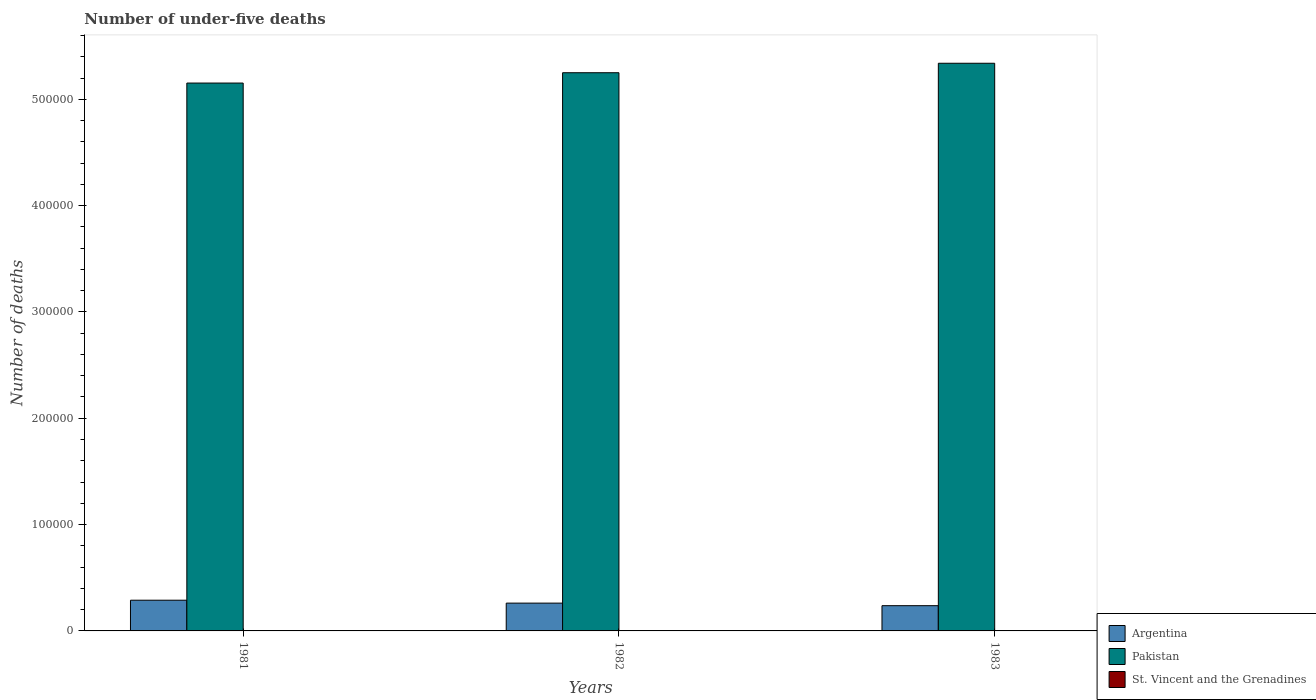Are the number of bars per tick equal to the number of legend labels?
Provide a succinct answer. Yes. Are the number of bars on each tick of the X-axis equal?
Your response must be concise. Yes. How many bars are there on the 2nd tick from the left?
Ensure brevity in your answer.  3. What is the label of the 2nd group of bars from the left?
Keep it short and to the point. 1982. What is the number of under-five deaths in St. Vincent and the Grenadines in 1982?
Make the answer very short. 140. Across all years, what is the maximum number of under-five deaths in Pakistan?
Give a very brief answer. 5.34e+05. Across all years, what is the minimum number of under-five deaths in Pakistan?
Keep it short and to the point. 5.15e+05. In which year was the number of under-five deaths in Pakistan maximum?
Make the answer very short. 1983. In which year was the number of under-five deaths in Argentina minimum?
Your response must be concise. 1983. What is the total number of under-five deaths in Argentina in the graph?
Provide a succinct answer. 7.88e+04. What is the difference between the number of under-five deaths in Pakistan in 1981 and that in 1982?
Make the answer very short. -9711. What is the difference between the number of under-five deaths in Argentina in 1982 and the number of under-five deaths in Pakistan in 1983?
Make the answer very short. -5.08e+05. What is the average number of under-five deaths in Pakistan per year?
Your answer should be very brief. 5.25e+05. In the year 1981, what is the difference between the number of under-five deaths in St. Vincent and the Grenadines and number of under-five deaths in Pakistan?
Give a very brief answer. -5.15e+05. What is the ratio of the number of under-five deaths in St. Vincent and the Grenadines in 1982 to that in 1983?
Your answer should be very brief. 1.11. Is the difference between the number of under-five deaths in St. Vincent and the Grenadines in 1982 and 1983 greater than the difference between the number of under-five deaths in Pakistan in 1982 and 1983?
Offer a very short reply. Yes. What is the difference between the highest and the lowest number of under-five deaths in St. Vincent and the Grenadines?
Your response must be concise. 30. Is the sum of the number of under-five deaths in St. Vincent and the Grenadines in 1981 and 1982 greater than the maximum number of under-five deaths in Argentina across all years?
Provide a short and direct response. No. What does the 1st bar from the left in 1982 represents?
Your response must be concise. Argentina. What does the 2nd bar from the right in 1981 represents?
Make the answer very short. Pakistan. How many bars are there?
Keep it short and to the point. 9. What is the difference between two consecutive major ticks on the Y-axis?
Keep it short and to the point. 1.00e+05. How many legend labels are there?
Your response must be concise. 3. What is the title of the graph?
Keep it short and to the point. Number of under-five deaths. What is the label or title of the Y-axis?
Give a very brief answer. Number of deaths. What is the Number of deaths in Argentina in 1981?
Give a very brief answer. 2.89e+04. What is the Number of deaths of Pakistan in 1981?
Your response must be concise. 5.15e+05. What is the Number of deaths of St. Vincent and the Grenadines in 1981?
Make the answer very short. 156. What is the Number of deaths of Argentina in 1982?
Offer a terse response. 2.61e+04. What is the Number of deaths of Pakistan in 1982?
Your response must be concise. 5.25e+05. What is the Number of deaths of St. Vincent and the Grenadines in 1982?
Your answer should be compact. 140. What is the Number of deaths of Argentina in 1983?
Keep it short and to the point. 2.37e+04. What is the Number of deaths of Pakistan in 1983?
Your response must be concise. 5.34e+05. What is the Number of deaths in St. Vincent and the Grenadines in 1983?
Ensure brevity in your answer.  126. Across all years, what is the maximum Number of deaths in Argentina?
Provide a short and direct response. 2.89e+04. Across all years, what is the maximum Number of deaths of Pakistan?
Provide a succinct answer. 5.34e+05. Across all years, what is the maximum Number of deaths in St. Vincent and the Grenadines?
Offer a terse response. 156. Across all years, what is the minimum Number of deaths in Argentina?
Your response must be concise. 2.37e+04. Across all years, what is the minimum Number of deaths in Pakistan?
Provide a short and direct response. 5.15e+05. Across all years, what is the minimum Number of deaths in St. Vincent and the Grenadines?
Your response must be concise. 126. What is the total Number of deaths of Argentina in the graph?
Your answer should be very brief. 7.88e+04. What is the total Number of deaths in Pakistan in the graph?
Provide a succinct answer. 1.57e+06. What is the total Number of deaths of St. Vincent and the Grenadines in the graph?
Your response must be concise. 422. What is the difference between the Number of deaths in Argentina in 1981 and that in 1982?
Make the answer very short. 2733. What is the difference between the Number of deaths of Pakistan in 1981 and that in 1982?
Provide a short and direct response. -9711. What is the difference between the Number of deaths in Argentina in 1981 and that in 1983?
Your answer should be compact. 5147. What is the difference between the Number of deaths in Pakistan in 1981 and that in 1983?
Your answer should be very brief. -1.86e+04. What is the difference between the Number of deaths of St. Vincent and the Grenadines in 1981 and that in 1983?
Keep it short and to the point. 30. What is the difference between the Number of deaths of Argentina in 1982 and that in 1983?
Make the answer very short. 2414. What is the difference between the Number of deaths of Pakistan in 1982 and that in 1983?
Your response must be concise. -8909. What is the difference between the Number of deaths in St. Vincent and the Grenadines in 1982 and that in 1983?
Ensure brevity in your answer.  14. What is the difference between the Number of deaths of Argentina in 1981 and the Number of deaths of Pakistan in 1982?
Make the answer very short. -4.96e+05. What is the difference between the Number of deaths of Argentina in 1981 and the Number of deaths of St. Vincent and the Grenadines in 1982?
Your answer should be compact. 2.87e+04. What is the difference between the Number of deaths in Pakistan in 1981 and the Number of deaths in St. Vincent and the Grenadines in 1982?
Your answer should be very brief. 5.15e+05. What is the difference between the Number of deaths in Argentina in 1981 and the Number of deaths in Pakistan in 1983?
Your answer should be very brief. -5.05e+05. What is the difference between the Number of deaths in Argentina in 1981 and the Number of deaths in St. Vincent and the Grenadines in 1983?
Keep it short and to the point. 2.88e+04. What is the difference between the Number of deaths of Pakistan in 1981 and the Number of deaths of St. Vincent and the Grenadines in 1983?
Your response must be concise. 5.15e+05. What is the difference between the Number of deaths in Argentina in 1982 and the Number of deaths in Pakistan in 1983?
Your answer should be compact. -5.08e+05. What is the difference between the Number of deaths in Argentina in 1982 and the Number of deaths in St. Vincent and the Grenadines in 1983?
Your response must be concise. 2.60e+04. What is the difference between the Number of deaths of Pakistan in 1982 and the Number of deaths of St. Vincent and the Grenadines in 1983?
Ensure brevity in your answer.  5.25e+05. What is the average Number of deaths of Argentina per year?
Ensure brevity in your answer.  2.63e+04. What is the average Number of deaths of Pakistan per year?
Ensure brevity in your answer.  5.25e+05. What is the average Number of deaths of St. Vincent and the Grenadines per year?
Ensure brevity in your answer.  140.67. In the year 1981, what is the difference between the Number of deaths of Argentina and Number of deaths of Pakistan?
Your answer should be very brief. -4.86e+05. In the year 1981, what is the difference between the Number of deaths in Argentina and Number of deaths in St. Vincent and the Grenadines?
Provide a succinct answer. 2.87e+04. In the year 1981, what is the difference between the Number of deaths in Pakistan and Number of deaths in St. Vincent and the Grenadines?
Keep it short and to the point. 5.15e+05. In the year 1982, what is the difference between the Number of deaths in Argentina and Number of deaths in Pakistan?
Keep it short and to the point. -4.99e+05. In the year 1982, what is the difference between the Number of deaths in Argentina and Number of deaths in St. Vincent and the Grenadines?
Make the answer very short. 2.60e+04. In the year 1982, what is the difference between the Number of deaths in Pakistan and Number of deaths in St. Vincent and the Grenadines?
Provide a succinct answer. 5.25e+05. In the year 1983, what is the difference between the Number of deaths in Argentina and Number of deaths in Pakistan?
Make the answer very short. -5.10e+05. In the year 1983, what is the difference between the Number of deaths of Argentina and Number of deaths of St. Vincent and the Grenadines?
Offer a terse response. 2.36e+04. In the year 1983, what is the difference between the Number of deaths of Pakistan and Number of deaths of St. Vincent and the Grenadines?
Keep it short and to the point. 5.34e+05. What is the ratio of the Number of deaths in Argentina in 1981 to that in 1982?
Give a very brief answer. 1.1. What is the ratio of the Number of deaths in Pakistan in 1981 to that in 1982?
Make the answer very short. 0.98. What is the ratio of the Number of deaths of St. Vincent and the Grenadines in 1981 to that in 1982?
Ensure brevity in your answer.  1.11. What is the ratio of the Number of deaths of Argentina in 1981 to that in 1983?
Offer a terse response. 1.22. What is the ratio of the Number of deaths of Pakistan in 1981 to that in 1983?
Make the answer very short. 0.97. What is the ratio of the Number of deaths of St. Vincent and the Grenadines in 1981 to that in 1983?
Your answer should be very brief. 1.24. What is the ratio of the Number of deaths of Argentina in 1982 to that in 1983?
Make the answer very short. 1.1. What is the ratio of the Number of deaths in Pakistan in 1982 to that in 1983?
Provide a succinct answer. 0.98. What is the difference between the highest and the second highest Number of deaths in Argentina?
Your answer should be very brief. 2733. What is the difference between the highest and the second highest Number of deaths of Pakistan?
Your response must be concise. 8909. What is the difference between the highest and the lowest Number of deaths of Argentina?
Provide a short and direct response. 5147. What is the difference between the highest and the lowest Number of deaths of Pakistan?
Your response must be concise. 1.86e+04. 